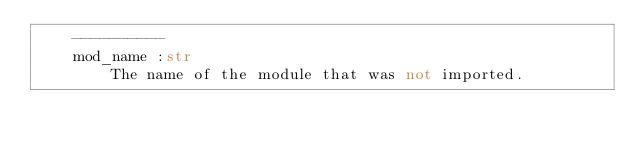Convert code to text. <code><loc_0><loc_0><loc_500><loc_500><_Python_>    ----------
    mod_name :str
        The name of the module that was not imported.
</code> 